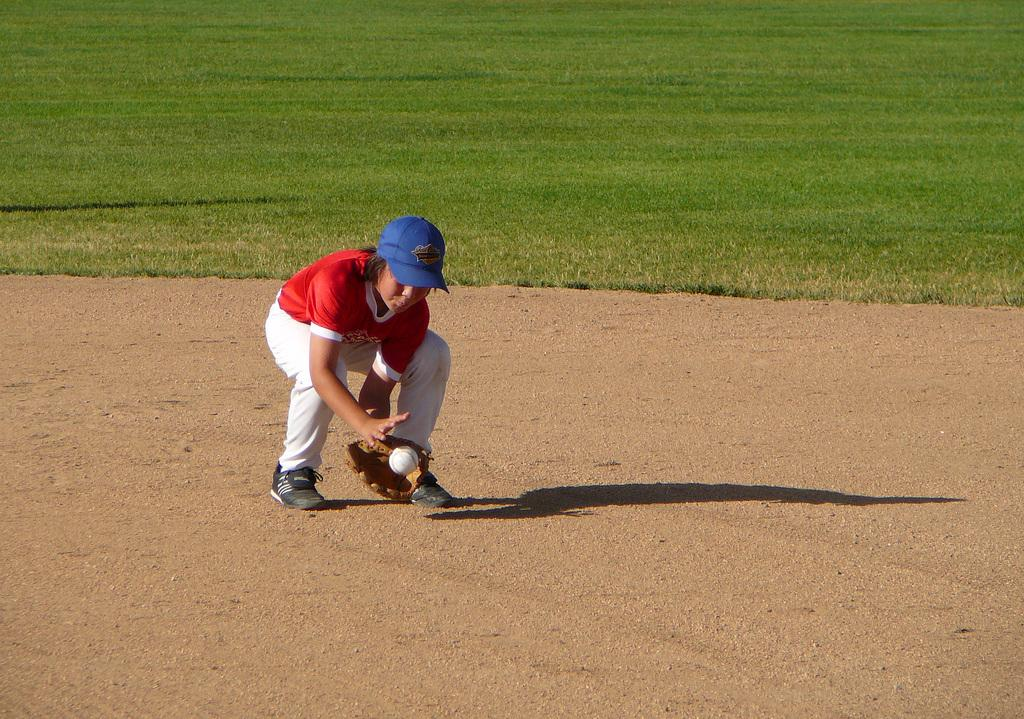What is the person in the image doing? The person is trying to catch a ball in the image. What color is the t-shirt the person is wearing? The person is wearing a red t-shirt. What color are the trousers the person is wearing? The person is wearing white trousers. What type of surface is visible in the image? There is grass visible in the image. What type of powder is being used by the person to improve their range in the image? There is no powder or indication of any substance being used to improve the person's range in the image. 